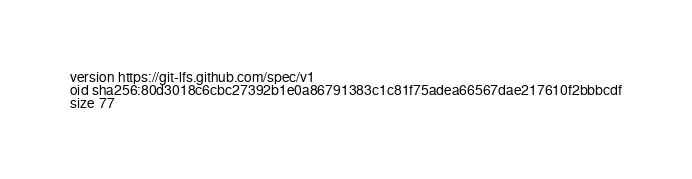Convert code to text. <code><loc_0><loc_0><loc_500><loc_500><_YAML_>version https://git-lfs.github.com/spec/v1
oid sha256:80d3018c6cbc27392b1e0a86791383c1c81f75adea66567dae217610f2bbbcdf
size 77
</code> 